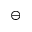<formula> <loc_0><loc_0><loc_500><loc_500>\ominus</formula> 